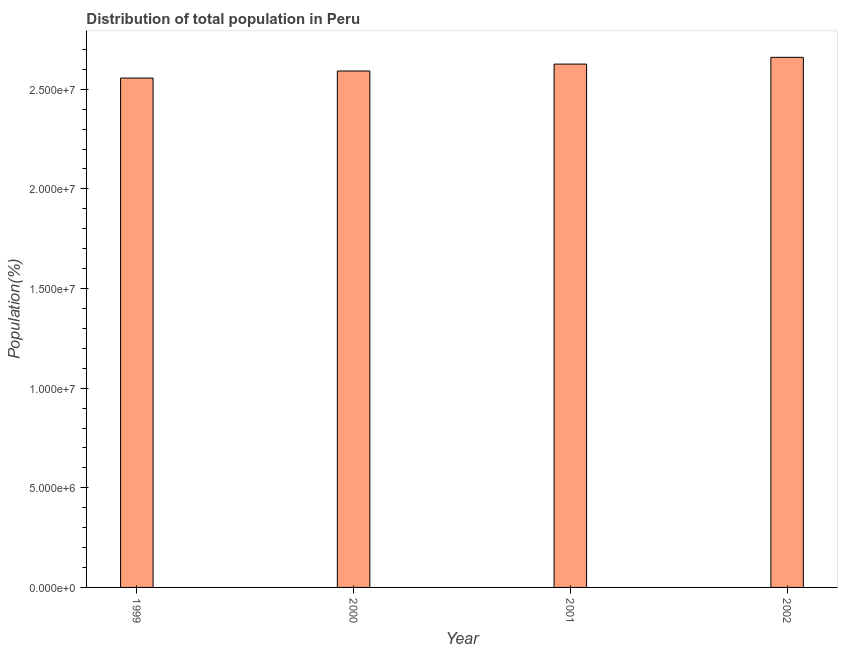What is the title of the graph?
Your answer should be very brief. Distribution of total population in Peru . What is the label or title of the X-axis?
Provide a succinct answer. Year. What is the label or title of the Y-axis?
Your answer should be very brief. Population(%). What is the population in 1999?
Provide a succinct answer. 2.56e+07. Across all years, what is the maximum population?
Your answer should be compact. 2.66e+07. Across all years, what is the minimum population?
Make the answer very short. 2.56e+07. In which year was the population minimum?
Provide a succinct answer. 1999. What is the sum of the population?
Provide a succinct answer. 1.04e+08. What is the difference between the population in 1999 and 2002?
Offer a terse response. -1.04e+06. What is the average population per year?
Make the answer very short. 2.61e+07. What is the median population?
Provide a succinct answer. 2.61e+07. Do a majority of the years between 2000 and 2001 (inclusive) have population greater than 17000000 %?
Provide a succinct answer. Yes. What is the ratio of the population in 2000 to that in 2001?
Keep it short and to the point. 0.99. Is the population in 2000 less than that in 2001?
Provide a succinct answer. Yes. Is the difference between the population in 1999 and 2000 greater than the difference between any two years?
Provide a succinct answer. No. What is the difference between the highest and the second highest population?
Offer a terse response. 3.40e+05. What is the difference between the highest and the lowest population?
Your answer should be compact. 1.04e+06. What is the difference between two consecutive major ticks on the Y-axis?
Provide a short and direct response. 5.00e+06. Are the values on the major ticks of Y-axis written in scientific E-notation?
Your response must be concise. Yes. What is the Population(%) of 1999?
Make the answer very short. 2.56e+07. What is the Population(%) in 2000?
Keep it short and to the point. 2.59e+07. What is the Population(%) of 2001?
Ensure brevity in your answer.  2.63e+07. What is the Population(%) in 2002?
Your answer should be very brief. 2.66e+07. What is the difference between the Population(%) in 1999 and 2000?
Give a very brief answer. -3.54e+05. What is the difference between the Population(%) in 1999 and 2001?
Your answer should be compact. -7.00e+05. What is the difference between the Population(%) in 1999 and 2002?
Keep it short and to the point. -1.04e+06. What is the difference between the Population(%) in 2000 and 2001?
Give a very brief answer. -3.46e+05. What is the difference between the Population(%) in 2000 and 2002?
Provide a short and direct response. -6.87e+05. What is the difference between the Population(%) in 2001 and 2002?
Your answer should be very brief. -3.40e+05. What is the ratio of the Population(%) in 1999 to that in 2002?
Offer a very short reply. 0.96. What is the ratio of the Population(%) in 2000 to that in 2001?
Give a very brief answer. 0.99. What is the ratio of the Population(%) in 2000 to that in 2002?
Offer a very short reply. 0.97. What is the ratio of the Population(%) in 2001 to that in 2002?
Offer a very short reply. 0.99. 